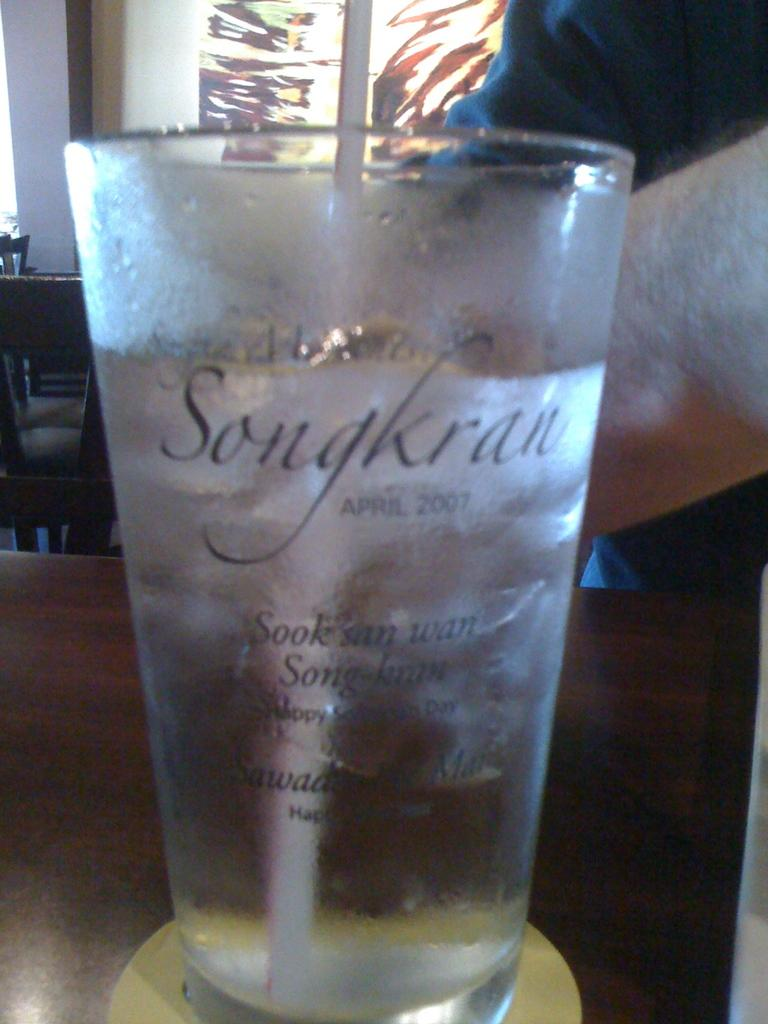<image>
Write a terse but informative summary of the picture. A glass labeled Sangkran with a straw at a restaurant 